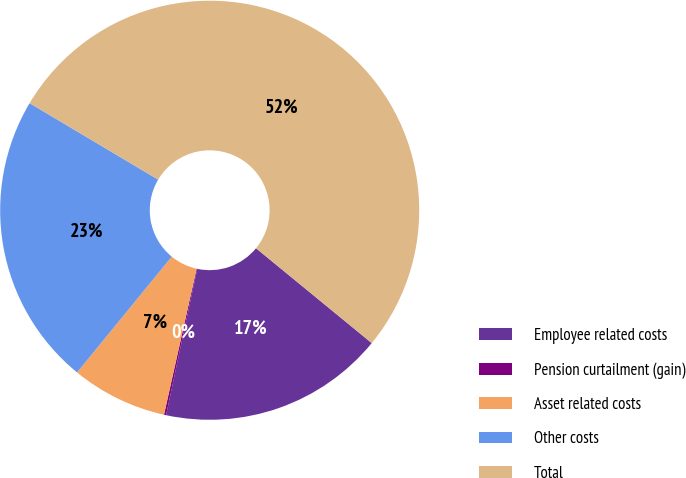<chart> <loc_0><loc_0><loc_500><loc_500><pie_chart><fcel>Employee related costs<fcel>Pension curtailment (gain)<fcel>Asset related costs<fcel>Other costs<fcel>Total<nl><fcel>17.41%<fcel>0.16%<fcel>7.41%<fcel>22.63%<fcel>52.39%<nl></chart> 